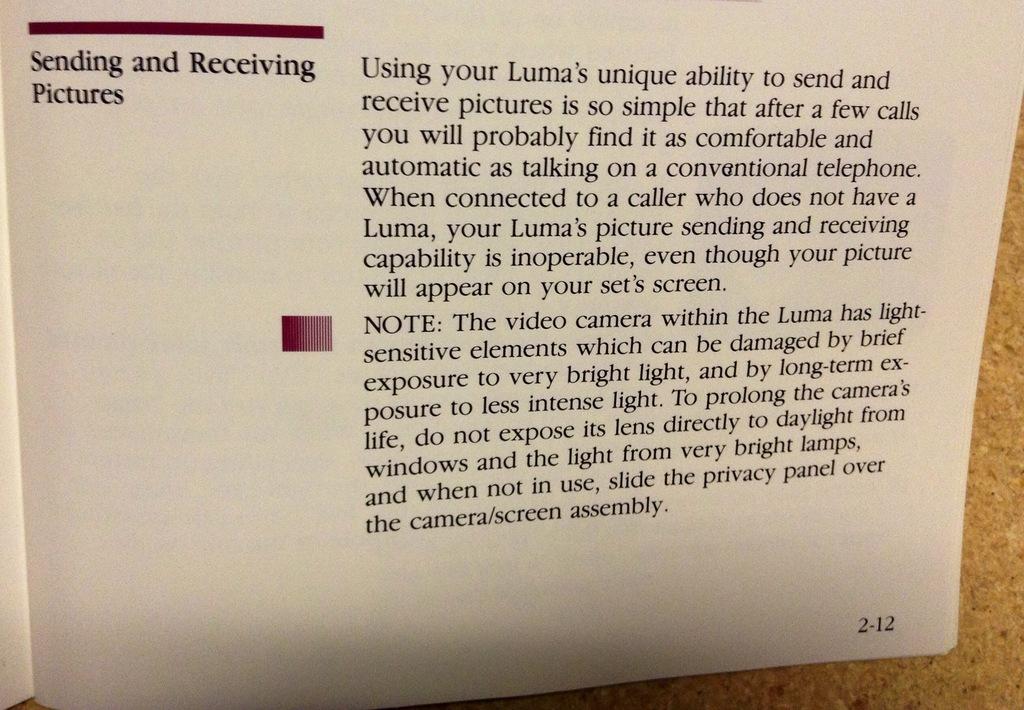What are the words on the left say?
Offer a very short reply. Sending and receiving pictures. What page is the book open to?
Offer a terse response. 2-12. 